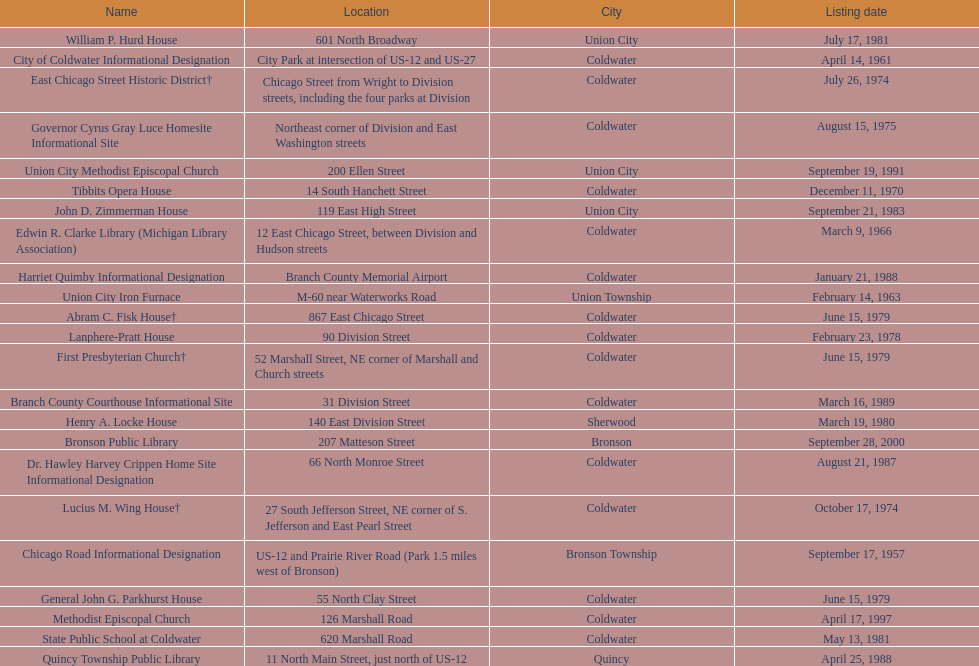How many years passed between the historic listing of public libraries in quincy and bronson? 12. 